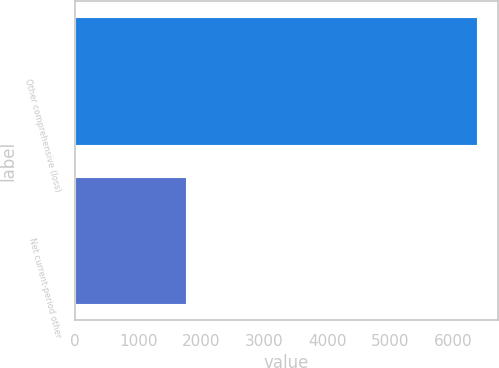Convert chart. <chart><loc_0><loc_0><loc_500><loc_500><bar_chart><fcel>Other comprehensive (loss)<fcel>Net current-period other<nl><fcel>6382<fcel>1752<nl></chart> 